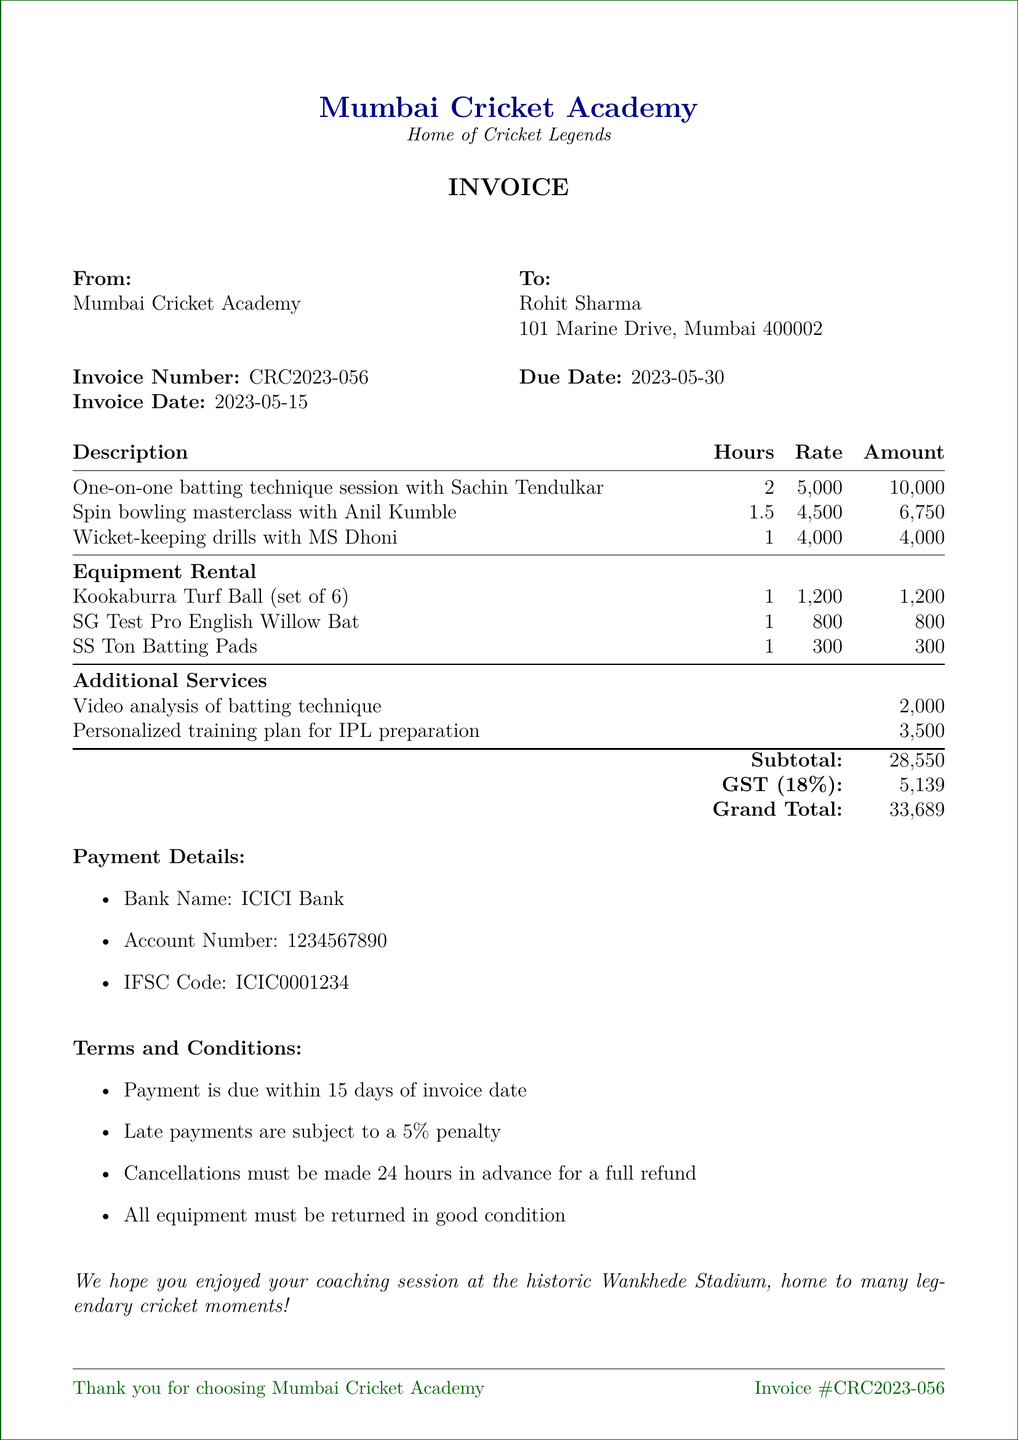What is the invoice number? The invoice number is listed in the document under invoice details.
Answer: CRC2023-056 Who is the invoice addressed to? The recipient of the invoice is mentioned in the "To" section of the document.
Answer: Rohit Sharma What is the total amount including GST? The total amount is stated clearly at the end of the invoice under "Grand Total."
Answer: ₹33,689 How many hours is the spin bowling masterclass with Anil Kumble? The hours for each coaching service are detailed in the invoice under the respective descriptions.
Answer: 1.5 What equipment is rented for ₹1,200? The document lists the rental items and their associated prices in the equipment rental section.
Answer: Kookaburra Turf Ball (set of 6) What is the rate per hour for wicket-keeping drills with MS Dhoni? The rate information is provided alongside the service descriptions in the document.
Answer: ₹4,000 When is the payment due? The due date is clearly stated in the invoice details section.
Answer: 2023-05-30 What penalty applies to late payments? The terms and conditions section mentions the implications of late payments.
Answer: 5% penalty Which bank details are provided for payment? Payment details are outlined clearly at the end of the document.
Answer: ICICI Bank 